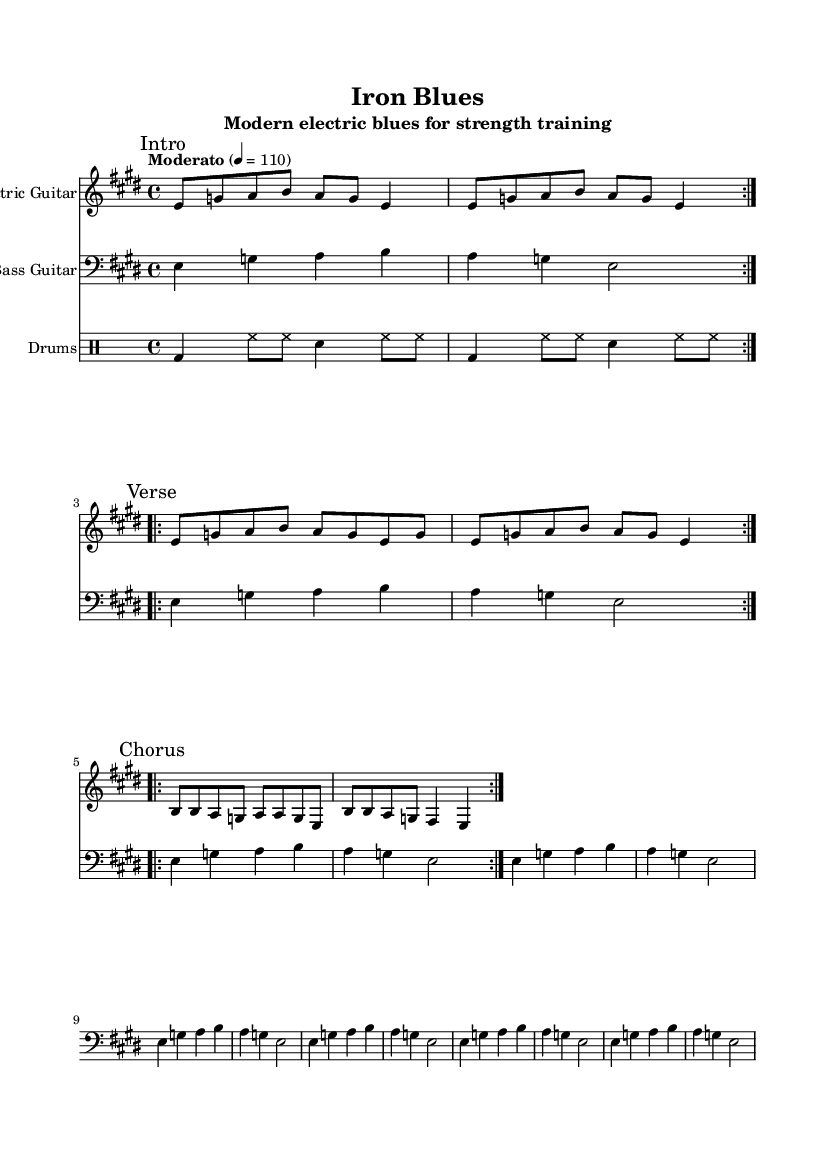What is the key signature of this music? The key signature is E major, which has four sharps (F#, C#, G#, D#). This is indicated at the beginning of the staff.
Answer: E major What is the time signature of this piece? The time signature is 4/4, which allows four beats per measure and is indicated at the beginning of the score.
Answer: 4/4 What tempo marking is used in this piece? The tempo marking is "Moderato" set at quarter note equals 110 beats per minute, which guides the performance speed.
Answer: Moderato How many bars are in the chorus section? The chorus section contains 8 bars, as indicated by the repeated volta markings and counting the measures in the staff.
Answer: 8 What instrument plays the main riff in this piece? The main riff is played by the Electric Guitar, as stated in the instrument name label on the staff.
Answer: Electric Guitar What drum pattern is used in this piece? The drum pattern consists of a bass drum, hi-hats, and snare, played in a steady rhythm that repeats throughout the section.
Answer: Bass, hi-hats, snare What is the typical structure of a blues song represented in this sheet music? The structure features an Intro, Verse, and Chorus, typical for blues music, allowing for call-and-response styles commonly found in this genre.
Answer: Intro, Verse, Chorus 